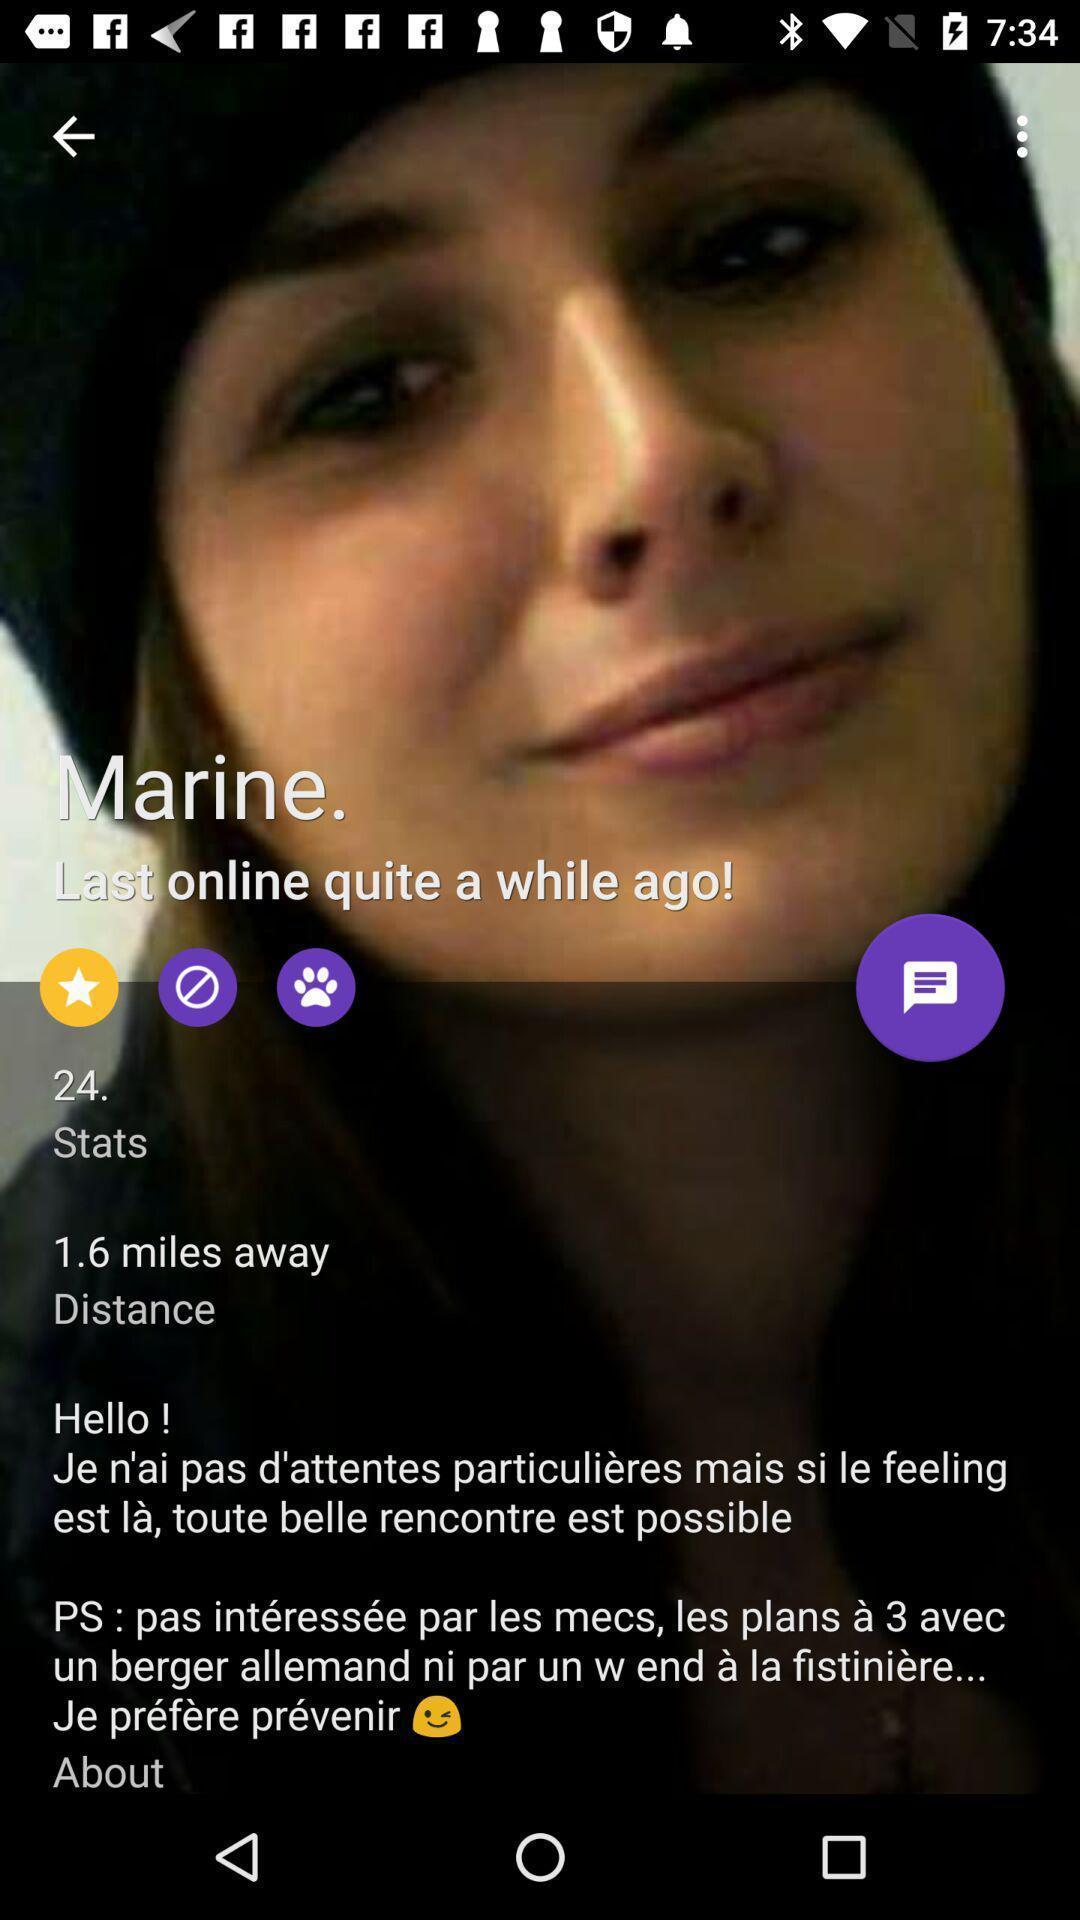Describe this image in words. Social app for chatting and dating. 